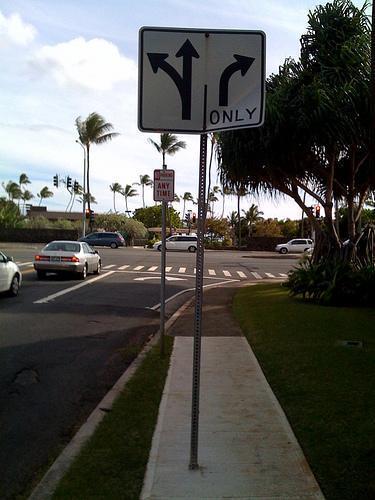How many people are in this picture?
Give a very brief answer. 0. 